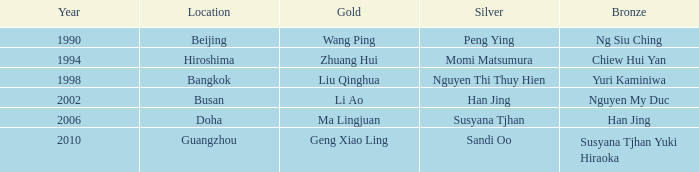What Gold has the Year of 2006? Ma Lingjuan. 